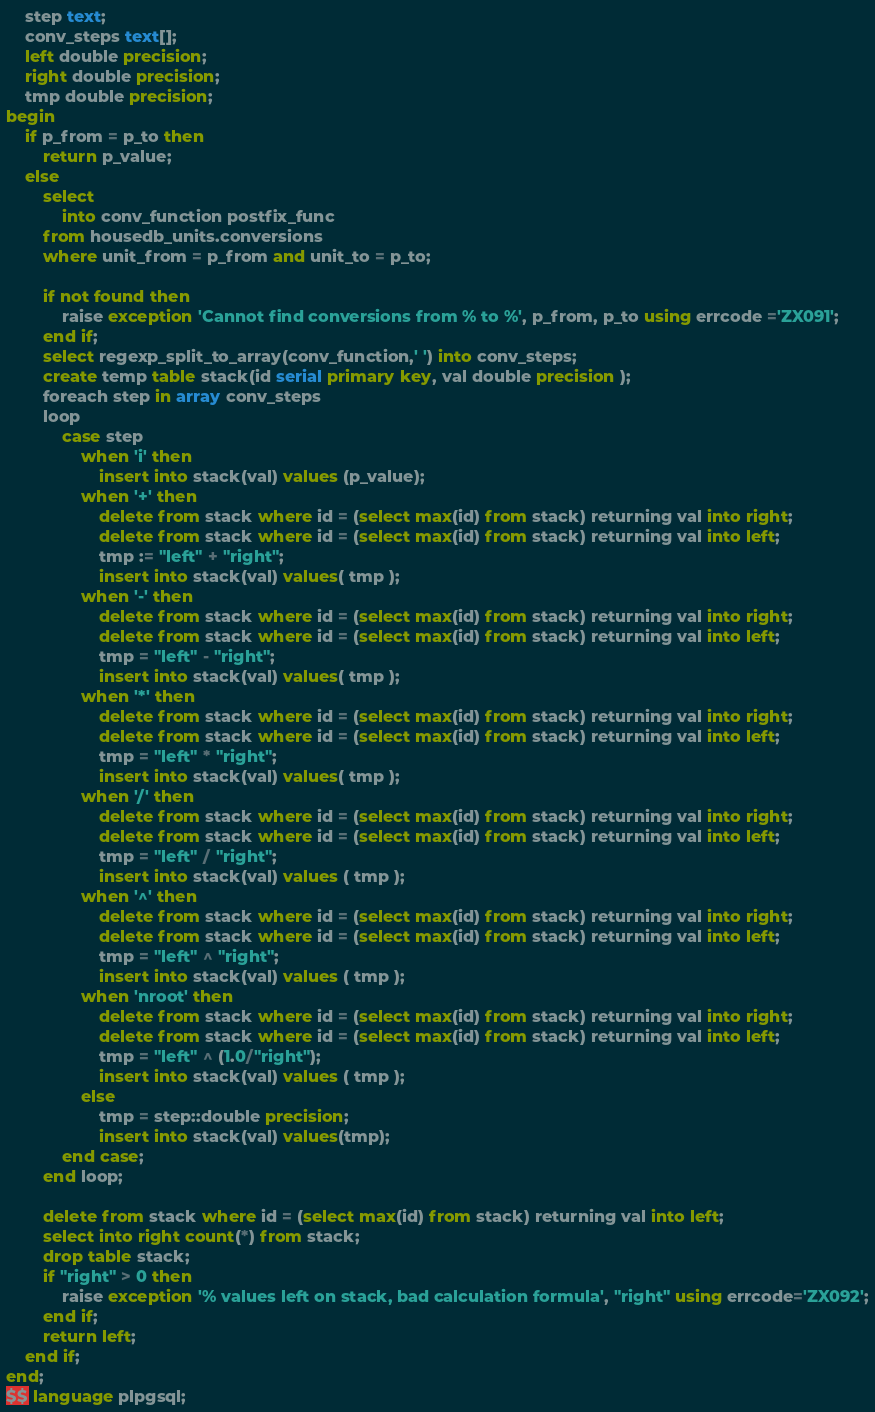<code> <loc_0><loc_0><loc_500><loc_500><_SQL_>    step text;
    conv_steps text[];    
    left double precision;
    right double precision;
    tmp double precision;
begin
    if p_from = p_to then
        return p_value;
    else
        select 
            into conv_function postfix_func
        from housedb_units.conversions
        where unit_from = p_from and unit_to = p_to;
            
        if not found then
            raise exception 'Cannot find conversions from % to %', p_from, p_to using errcode ='ZX091';
        end if;
        select regexp_split_to_array(conv_function,' ') into conv_steps;
        create temp table stack(id serial primary key, val double precision );
        foreach step in array conv_steps
        loop
            case step 
                when 'i' then
                    insert into stack(val) values (p_value);
                when '+' then
                    delete from stack where id = (select max(id) from stack) returning val into right;
                    delete from stack where id = (select max(id) from stack) returning val into left;
                    tmp := "left" + "right";
                    insert into stack(val) values( tmp );
                when '-' then
                    delete from stack where id = (select max(id) from stack) returning val into right;
                    delete from stack where id = (select max(id) from stack) returning val into left;
                    tmp = "left" - "right";
                    insert into stack(val) values( tmp );
                when '*' then
                    delete from stack where id = (select max(id) from stack) returning val into right;
                    delete from stack where id = (select max(id) from stack) returning val into left;
                    tmp = "left" * "right";
                    insert into stack(val) values( tmp );
                when '/' then
                    delete from stack where id = (select max(id) from stack) returning val into right;
                    delete from stack where id = (select max(id) from stack) returning val into left;
                    tmp = "left" / "right";
                    insert into stack(val) values ( tmp );
                when '^' then
                    delete from stack where id = (select max(id) from stack) returning val into right;
                    delete from stack where id = (select max(id) from stack) returning val into left;
                    tmp = "left" ^ "right";
                    insert into stack(val) values ( tmp );
                when 'nroot' then
                    delete from stack where id = (select max(id) from stack) returning val into right;
                    delete from stack where id = (select max(id) from stack) returning val into left;
                    tmp = "left" ^ (1.0/"right");
                    insert into stack(val) values ( tmp );
                else
                    tmp = step::double precision;
                    insert into stack(val) values(tmp);
            end case;
        end loop;
        
        delete from stack where id = (select max(id) from stack) returning val into left;
        select into right count(*) from stack;
        drop table stack;
        if "right" > 0 then
            raise exception '% values left on stack, bad calculation formula', "right" using errcode='ZX092';
        end if;
        return left;
    end if;
end;
$$ language plpgsql;</code> 